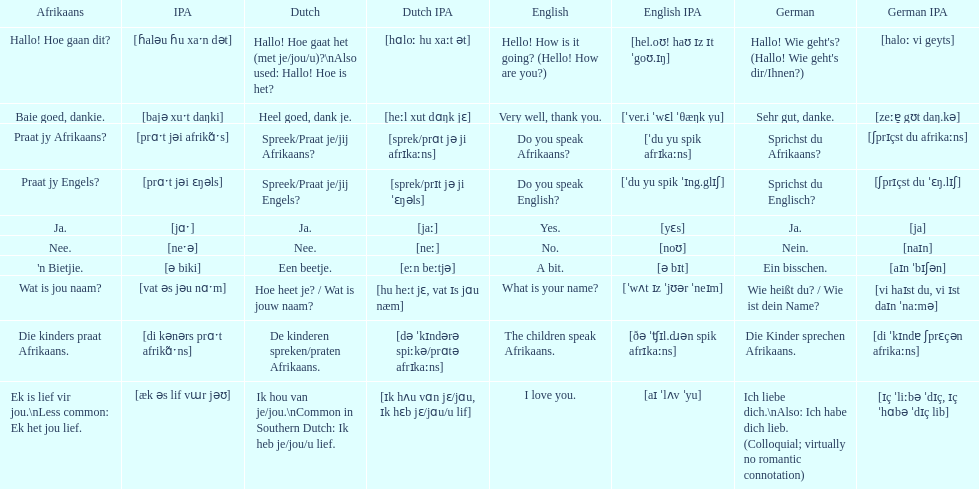How do you say 'yes' in afrikaans? Ja. 